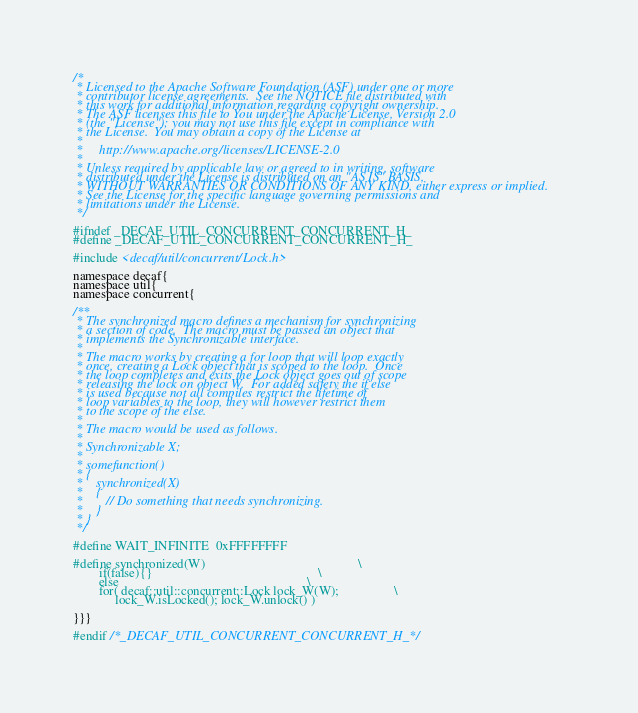Convert code to text. <code><loc_0><loc_0><loc_500><loc_500><_C_>/*
 * Licensed to the Apache Software Foundation (ASF) under one or more
 * contributor license agreements.  See the NOTICE file distributed with
 * this work for additional information regarding copyright ownership.
 * The ASF licenses this file to You under the Apache License, Version 2.0
 * (the "License"); you may not use this file except in compliance with
 * the License.  You may obtain a copy of the License at
 *
 *     http://www.apache.org/licenses/LICENSE-2.0
 *
 * Unless required by applicable law or agreed to in writing, software
 * distributed under the License is distributed on an "AS IS" BASIS,
 * WITHOUT WARRANTIES OR CONDITIONS OF ANY KIND, either express or implied.
 * See the License for the specific language governing permissions and
 * limitations under the License.
 */

#ifndef _DECAF_UTIL_CONCURRENT_CONCURRENT_H_
#define _DECAF_UTIL_CONCURRENT_CONCURRENT_H_

#include <decaf/util/concurrent/Lock.h>

namespace decaf{
namespace util{
namespace concurrent{

/**
 * The synchronized macro defines a mechanism for synchronizing
 * a section of code.  The macro must be passed an object that
 * implements the Synchronizable interface.
 *
 * The macro works by creating a for loop that will loop exactly
 * once, creating a Lock object that is scoped to the loop.  Once
 * the loop completes and exits the Lock object goes out of scope
 * releasing the lock on object W.  For added safety the if else
 * is used because not all compiles restrict the lifetime of
 * loop variables to the loop, they will however restrict them
 * to the scope of the else.
 *
 * The macro would be used as follows.
 *
 * Synchronizable X;
 *
 * somefunction()
 * {
 *    synchronized(X)
 *    {
 *       // Do something that needs synchronizing.
 *    }
 * }
 */

#define WAIT_INFINITE  0xFFFFFFFF

#define synchronized(W)                                               \
        if(false){}                                                   \
        else                                                          \
        for( decaf::util::concurrent::Lock lock_W(W);                 \
             lock_W.isLocked(); lock_W.unlock() )

}}}

#endif /*_DECAF_UTIL_CONCURRENT_CONCURRENT_H_*/
</code> 